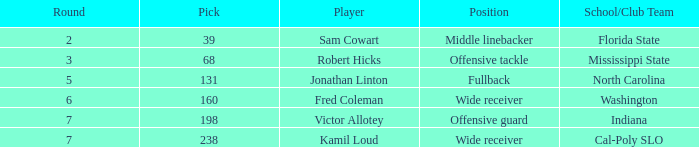Which Player has a Round smaller than 5, and a School/Club Team of florida state? Sam Cowart. 